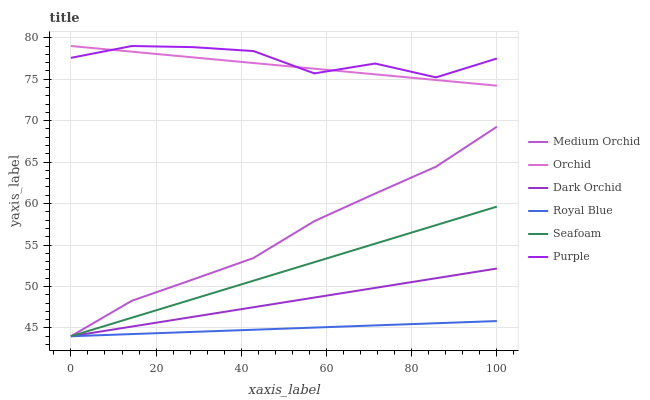Does Royal Blue have the minimum area under the curve?
Answer yes or no. Yes. Does Purple have the maximum area under the curve?
Answer yes or no. Yes. Does Medium Orchid have the minimum area under the curve?
Answer yes or no. No. Does Medium Orchid have the maximum area under the curve?
Answer yes or no. No. Is Royal Blue the smoothest?
Answer yes or no. Yes. Is Purple the roughest?
Answer yes or no. Yes. Is Medium Orchid the smoothest?
Answer yes or no. No. Is Medium Orchid the roughest?
Answer yes or no. No. Does Orchid have the lowest value?
Answer yes or no. No. Does Orchid have the highest value?
Answer yes or no. Yes. Does Medium Orchid have the highest value?
Answer yes or no. No. Is Royal Blue less than Purple?
Answer yes or no. Yes. Is Orchid greater than Seafoam?
Answer yes or no. Yes. Does Purple intersect Orchid?
Answer yes or no. Yes. Is Purple less than Orchid?
Answer yes or no. No. Is Purple greater than Orchid?
Answer yes or no. No. Does Royal Blue intersect Purple?
Answer yes or no. No. 